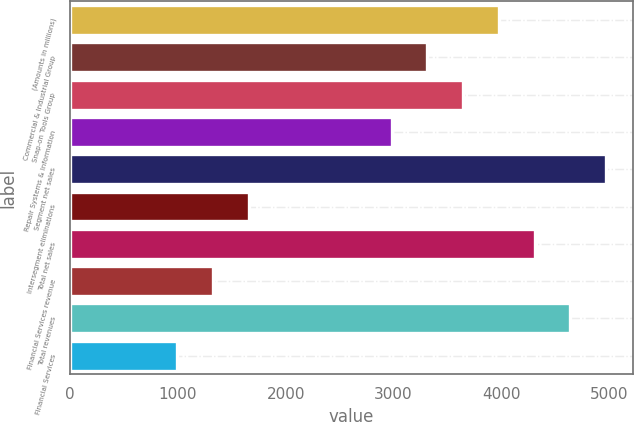Convert chart. <chart><loc_0><loc_0><loc_500><loc_500><bar_chart><fcel>(Amounts in millions)<fcel>Commercial & Industrial Group<fcel>Snap-on Tools Group<fcel>Repair Systems & Information<fcel>Segment net sales<fcel>Intersegment eliminations<fcel>Total net sales<fcel>Financial Services revenue<fcel>Total revenues<fcel>Financial Services<nl><fcel>3977.92<fcel>3315<fcel>3646.46<fcel>2983.54<fcel>4972.3<fcel>1657.7<fcel>4309.38<fcel>1326.24<fcel>4640.84<fcel>994.78<nl></chart> 